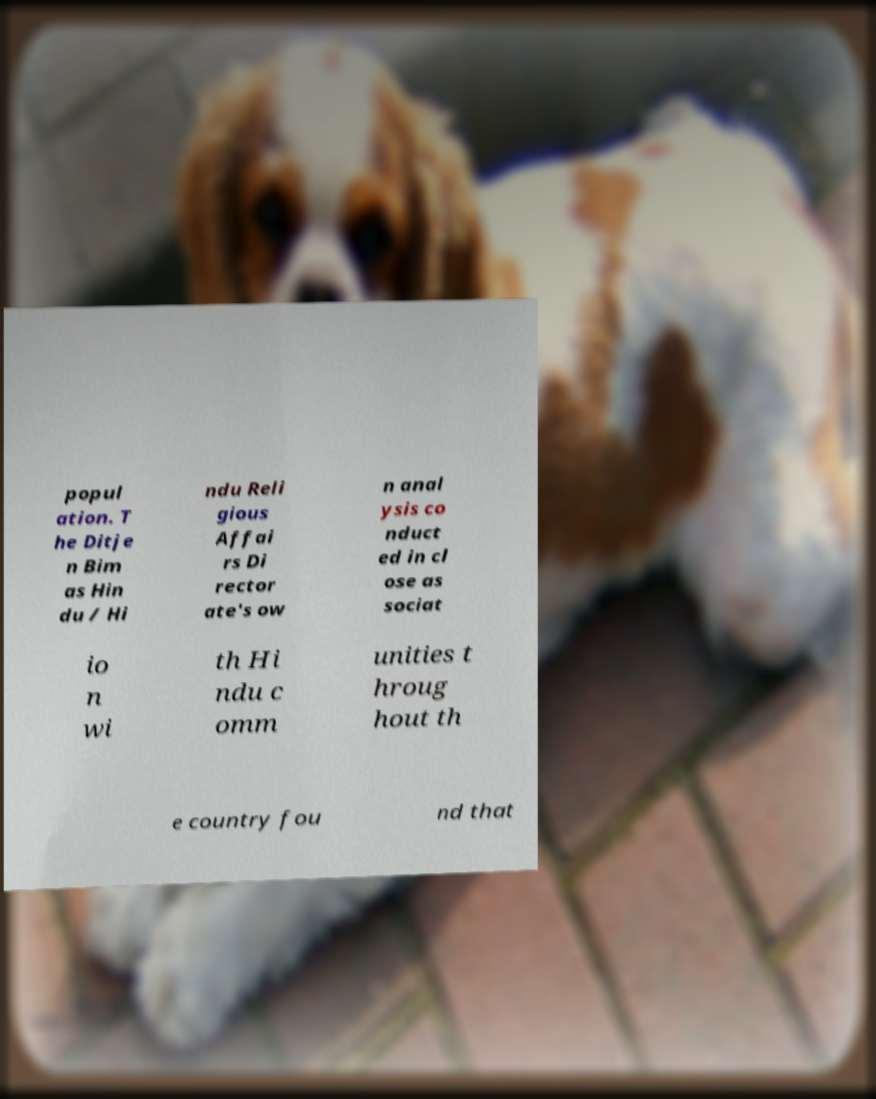Can you read and provide the text displayed in the image?This photo seems to have some interesting text. Can you extract and type it out for me? popul ation. T he Ditje n Bim as Hin du / Hi ndu Reli gious Affai rs Di rector ate's ow n anal ysis co nduct ed in cl ose as sociat io n wi th Hi ndu c omm unities t hroug hout th e country fou nd that 